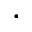Convert formula to latex. <formula><loc_0><loc_0><loc_500><loc_500>\ll a n g l e \cdot \ r r a n g l e</formula> 